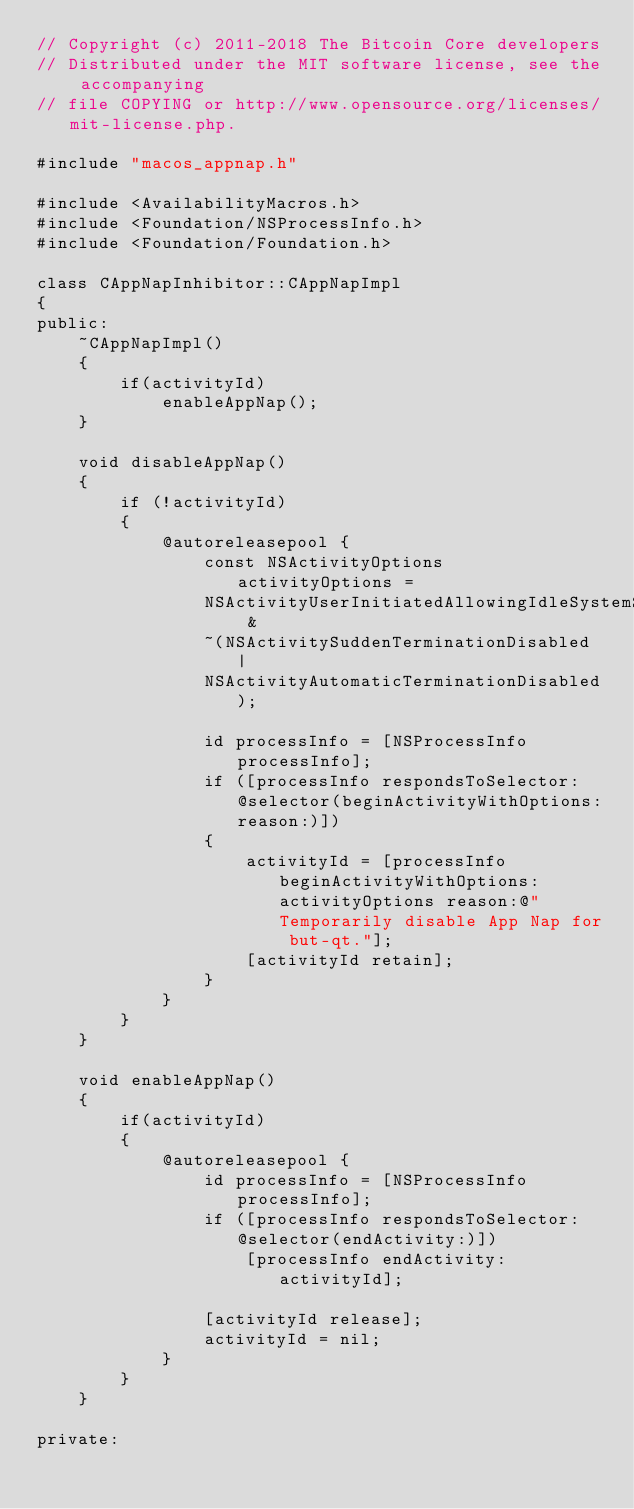Convert code to text. <code><loc_0><loc_0><loc_500><loc_500><_ObjectiveC_>// Copyright (c) 2011-2018 The Bitcoin Core developers
// Distributed under the MIT software license, see the accompanying
// file COPYING or http://www.opensource.org/licenses/mit-license.php.

#include "macos_appnap.h"

#include <AvailabilityMacros.h>
#include <Foundation/NSProcessInfo.h>
#include <Foundation/Foundation.h>

class CAppNapInhibitor::CAppNapImpl
{
public:
    ~CAppNapImpl()
    {
        if(activityId)
            enableAppNap();
    }

    void disableAppNap()
    {
        if (!activityId)
        {
            @autoreleasepool {
                const NSActivityOptions activityOptions =
                NSActivityUserInitiatedAllowingIdleSystemSleep &
                ~(NSActivitySuddenTerminationDisabled |
                NSActivityAutomaticTerminationDisabled);

                id processInfo = [NSProcessInfo processInfo];
                if ([processInfo respondsToSelector:@selector(beginActivityWithOptions:reason:)])
                {
                    activityId = [processInfo beginActivityWithOptions: activityOptions reason:@"Temporarily disable App Nap for but-qt."];
                    [activityId retain];
                }
            }
        }
    }

    void enableAppNap()
    {
        if(activityId)
        {
            @autoreleasepool {
                id processInfo = [NSProcessInfo processInfo];
                if ([processInfo respondsToSelector:@selector(endActivity:)])
                    [processInfo endActivity:activityId];

                [activityId release];
                activityId = nil;
            }
        }
    }

private:</code> 